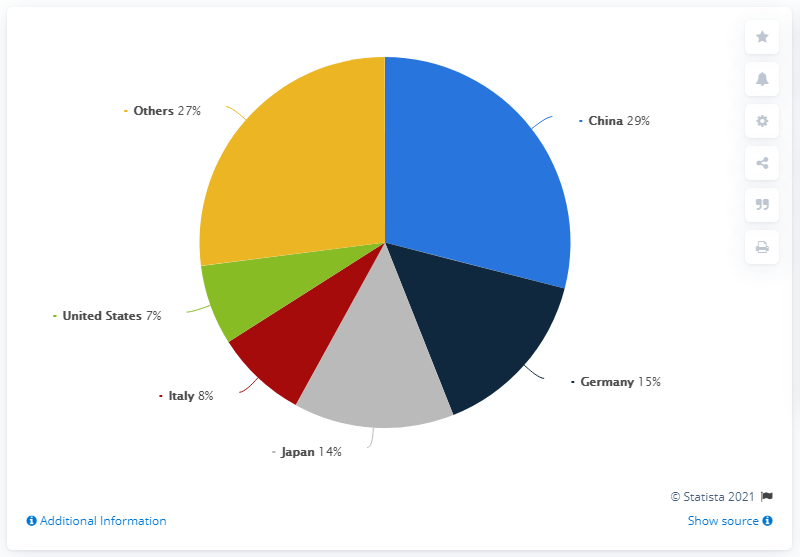Specify some key components in this picture. In 2020, the country with the highest market share of machine tool producers had a percentage difference of 22% compared to the country with the lowest market share. In 2020, China was the country with the highest market share of machine tool producers, accounting for the majority of global production. According to statistics from 2020, Germany accounted for 15 percent of the world's machine tool production, making it the top producing country in the world in this regard. 